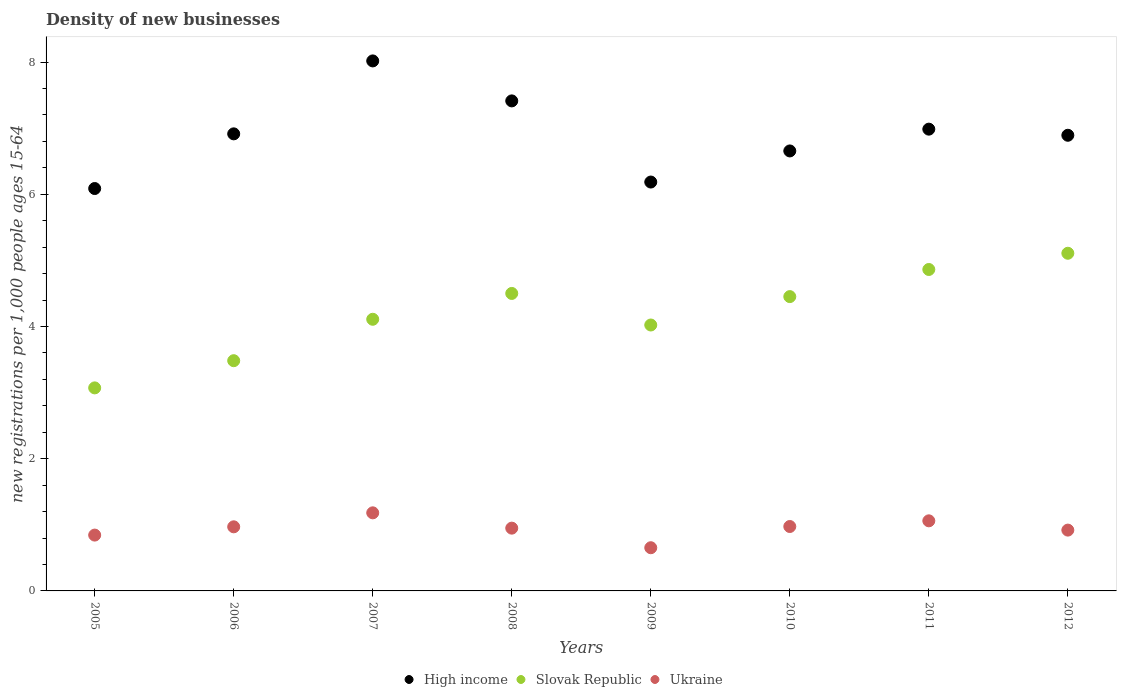What is the number of new registrations in Slovak Republic in 2011?
Give a very brief answer. 4.86. Across all years, what is the maximum number of new registrations in Ukraine?
Your answer should be very brief. 1.18. Across all years, what is the minimum number of new registrations in Ukraine?
Your response must be concise. 0.65. What is the total number of new registrations in Slovak Republic in the graph?
Provide a succinct answer. 33.61. What is the difference between the number of new registrations in High income in 2006 and that in 2009?
Your response must be concise. 0.73. What is the difference between the number of new registrations in High income in 2011 and the number of new registrations in Ukraine in 2009?
Your answer should be compact. 6.33. What is the average number of new registrations in Ukraine per year?
Offer a very short reply. 0.94. In the year 2010, what is the difference between the number of new registrations in Slovak Republic and number of new registrations in High income?
Give a very brief answer. -2.2. What is the ratio of the number of new registrations in Slovak Republic in 2007 to that in 2009?
Give a very brief answer. 1.02. Is the difference between the number of new registrations in Slovak Republic in 2005 and 2011 greater than the difference between the number of new registrations in High income in 2005 and 2011?
Your answer should be compact. No. What is the difference between the highest and the second highest number of new registrations in Ukraine?
Your response must be concise. 0.12. What is the difference between the highest and the lowest number of new registrations in Ukraine?
Offer a very short reply. 0.53. Is the sum of the number of new registrations in High income in 2006 and 2009 greater than the maximum number of new registrations in Slovak Republic across all years?
Your answer should be compact. Yes. Is it the case that in every year, the sum of the number of new registrations in Slovak Republic and number of new registrations in Ukraine  is greater than the number of new registrations in High income?
Give a very brief answer. No. Does the number of new registrations in Ukraine monotonically increase over the years?
Ensure brevity in your answer.  No. Is the number of new registrations in Ukraine strictly less than the number of new registrations in High income over the years?
Provide a succinct answer. Yes. How many dotlines are there?
Provide a short and direct response. 3. How many years are there in the graph?
Your answer should be very brief. 8. Are the values on the major ticks of Y-axis written in scientific E-notation?
Your answer should be compact. No. Does the graph contain grids?
Your answer should be very brief. No. Where does the legend appear in the graph?
Keep it short and to the point. Bottom center. What is the title of the graph?
Your answer should be compact. Density of new businesses. Does "Egypt, Arab Rep." appear as one of the legend labels in the graph?
Provide a short and direct response. No. What is the label or title of the X-axis?
Offer a terse response. Years. What is the label or title of the Y-axis?
Provide a short and direct response. New registrations per 1,0 people ages 15-64. What is the new registrations per 1,000 people ages 15-64 of High income in 2005?
Ensure brevity in your answer.  6.09. What is the new registrations per 1,000 people ages 15-64 in Slovak Republic in 2005?
Provide a short and direct response. 3.07. What is the new registrations per 1,000 people ages 15-64 of Ukraine in 2005?
Your answer should be compact. 0.84. What is the new registrations per 1,000 people ages 15-64 of High income in 2006?
Make the answer very short. 6.91. What is the new registrations per 1,000 people ages 15-64 in Slovak Republic in 2006?
Your answer should be compact. 3.48. What is the new registrations per 1,000 people ages 15-64 of Ukraine in 2006?
Offer a terse response. 0.97. What is the new registrations per 1,000 people ages 15-64 of High income in 2007?
Ensure brevity in your answer.  8.02. What is the new registrations per 1,000 people ages 15-64 in Slovak Republic in 2007?
Provide a short and direct response. 4.11. What is the new registrations per 1,000 people ages 15-64 in Ukraine in 2007?
Your answer should be compact. 1.18. What is the new registrations per 1,000 people ages 15-64 in High income in 2008?
Give a very brief answer. 7.41. What is the new registrations per 1,000 people ages 15-64 of Slovak Republic in 2008?
Offer a terse response. 4.5. What is the new registrations per 1,000 people ages 15-64 in Ukraine in 2008?
Your response must be concise. 0.95. What is the new registrations per 1,000 people ages 15-64 of High income in 2009?
Keep it short and to the point. 6.19. What is the new registrations per 1,000 people ages 15-64 of Slovak Republic in 2009?
Give a very brief answer. 4.02. What is the new registrations per 1,000 people ages 15-64 in Ukraine in 2009?
Your answer should be very brief. 0.65. What is the new registrations per 1,000 people ages 15-64 in High income in 2010?
Your response must be concise. 6.66. What is the new registrations per 1,000 people ages 15-64 in Slovak Republic in 2010?
Ensure brevity in your answer.  4.45. What is the new registrations per 1,000 people ages 15-64 in Ukraine in 2010?
Offer a terse response. 0.97. What is the new registrations per 1,000 people ages 15-64 of High income in 2011?
Ensure brevity in your answer.  6.99. What is the new registrations per 1,000 people ages 15-64 in Slovak Republic in 2011?
Ensure brevity in your answer.  4.86. What is the new registrations per 1,000 people ages 15-64 of Ukraine in 2011?
Ensure brevity in your answer.  1.06. What is the new registrations per 1,000 people ages 15-64 of High income in 2012?
Your response must be concise. 6.89. What is the new registrations per 1,000 people ages 15-64 of Slovak Republic in 2012?
Offer a very short reply. 5.11. Across all years, what is the maximum new registrations per 1,000 people ages 15-64 of High income?
Make the answer very short. 8.02. Across all years, what is the maximum new registrations per 1,000 people ages 15-64 in Slovak Republic?
Your answer should be compact. 5.11. Across all years, what is the maximum new registrations per 1,000 people ages 15-64 in Ukraine?
Give a very brief answer. 1.18. Across all years, what is the minimum new registrations per 1,000 people ages 15-64 of High income?
Your answer should be very brief. 6.09. Across all years, what is the minimum new registrations per 1,000 people ages 15-64 of Slovak Republic?
Offer a terse response. 3.07. Across all years, what is the minimum new registrations per 1,000 people ages 15-64 in Ukraine?
Provide a succinct answer. 0.65. What is the total new registrations per 1,000 people ages 15-64 of High income in the graph?
Ensure brevity in your answer.  55.15. What is the total new registrations per 1,000 people ages 15-64 of Slovak Republic in the graph?
Make the answer very short. 33.61. What is the total new registrations per 1,000 people ages 15-64 of Ukraine in the graph?
Provide a short and direct response. 7.55. What is the difference between the new registrations per 1,000 people ages 15-64 of High income in 2005 and that in 2006?
Your response must be concise. -0.83. What is the difference between the new registrations per 1,000 people ages 15-64 in Slovak Republic in 2005 and that in 2006?
Your response must be concise. -0.41. What is the difference between the new registrations per 1,000 people ages 15-64 in Ukraine in 2005 and that in 2006?
Your answer should be compact. -0.13. What is the difference between the new registrations per 1,000 people ages 15-64 in High income in 2005 and that in 2007?
Your answer should be very brief. -1.93. What is the difference between the new registrations per 1,000 people ages 15-64 of Slovak Republic in 2005 and that in 2007?
Keep it short and to the point. -1.04. What is the difference between the new registrations per 1,000 people ages 15-64 in Ukraine in 2005 and that in 2007?
Offer a very short reply. -0.34. What is the difference between the new registrations per 1,000 people ages 15-64 of High income in 2005 and that in 2008?
Your response must be concise. -1.33. What is the difference between the new registrations per 1,000 people ages 15-64 of Slovak Republic in 2005 and that in 2008?
Your answer should be very brief. -1.43. What is the difference between the new registrations per 1,000 people ages 15-64 of Ukraine in 2005 and that in 2008?
Offer a terse response. -0.11. What is the difference between the new registrations per 1,000 people ages 15-64 of High income in 2005 and that in 2009?
Keep it short and to the point. -0.1. What is the difference between the new registrations per 1,000 people ages 15-64 of Slovak Republic in 2005 and that in 2009?
Offer a terse response. -0.95. What is the difference between the new registrations per 1,000 people ages 15-64 of Ukraine in 2005 and that in 2009?
Offer a very short reply. 0.19. What is the difference between the new registrations per 1,000 people ages 15-64 of High income in 2005 and that in 2010?
Keep it short and to the point. -0.57. What is the difference between the new registrations per 1,000 people ages 15-64 of Slovak Republic in 2005 and that in 2010?
Provide a short and direct response. -1.38. What is the difference between the new registrations per 1,000 people ages 15-64 in Ukraine in 2005 and that in 2010?
Make the answer very short. -0.13. What is the difference between the new registrations per 1,000 people ages 15-64 in High income in 2005 and that in 2011?
Your response must be concise. -0.9. What is the difference between the new registrations per 1,000 people ages 15-64 in Slovak Republic in 2005 and that in 2011?
Your answer should be compact. -1.79. What is the difference between the new registrations per 1,000 people ages 15-64 in Ukraine in 2005 and that in 2011?
Make the answer very short. -0.22. What is the difference between the new registrations per 1,000 people ages 15-64 of High income in 2005 and that in 2012?
Your response must be concise. -0.81. What is the difference between the new registrations per 1,000 people ages 15-64 in Slovak Republic in 2005 and that in 2012?
Provide a succinct answer. -2.04. What is the difference between the new registrations per 1,000 people ages 15-64 of Ukraine in 2005 and that in 2012?
Ensure brevity in your answer.  -0.08. What is the difference between the new registrations per 1,000 people ages 15-64 in High income in 2006 and that in 2007?
Give a very brief answer. -1.1. What is the difference between the new registrations per 1,000 people ages 15-64 of Slovak Republic in 2006 and that in 2007?
Make the answer very short. -0.63. What is the difference between the new registrations per 1,000 people ages 15-64 in Ukraine in 2006 and that in 2007?
Make the answer very short. -0.21. What is the difference between the new registrations per 1,000 people ages 15-64 in High income in 2006 and that in 2008?
Keep it short and to the point. -0.5. What is the difference between the new registrations per 1,000 people ages 15-64 in Slovak Republic in 2006 and that in 2008?
Provide a succinct answer. -1.02. What is the difference between the new registrations per 1,000 people ages 15-64 in Ukraine in 2006 and that in 2008?
Your answer should be compact. 0.02. What is the difference between the new registrations per 1,000 people ages 15-64 in High income in 2006 and that in 2009?
Give a very brief answer. 0.73. What is the difference between the new registrations per 1,000 people ages 15-64 of Slovak Republic in 2006 and that in 2009?
Offer a very short reply. -0.54. What is the difference between the new registrations per 1,000 people ages 15-64 of Ukraine in 2006 and that in 2009?
Give a very brief answer. 0.32. What is the difference between the new registrations per 1,000 people ages 15-64 of High income in 2006 and that in 2010?
Provide a short and direct response. 0.26. What is the difference between the new registrations per 1,000 people ages 15-64 of Slovak Republic in 2006 and that in 2010?
Your answer should be very brief. -0.97. What is the difference between the new registrations per 1,000 people ages 15-64 in Ukraine in 2006 and that in 2010?
Offer a terse response. -0. What is the difference between the new registrations per 1,000 people ages 15-64 of High income in 2006 and that in 2011?
Make the answer very short. -0.07. What is the difference between the new registrations per 1,000 people ages 15-64 in Slovak Republic in 2006 and that in 2011?
Keep it short and to the point. -1.38. What is the difference between the new registrations per 1,000 people ages 15-64 in Ukraine in 2006 and that in 2011?
Your answer should be very brief. -0.09. What is the difference between the new registrations per 1,000 people ages 15-64 in High income in 2006 and that in 2012?
Make the answer very short. 0.02. What is the difference between the new registrations per 1,000 people ages 15-64 of Slovak Republic in 2006 and that in 2012?
Your response must be concise. -1.63. What is the difference between the new registrations per 1,000 people ages 15-64 in Ukraine in 2006 and that in 2012?
Give a very brief answer. 0.05. What is the difference between the new registrations per 1,000 people ages 15-64 in High income in 2007 and that in 2008?
Provide a short and direct response. 0.6. What is the difference between the new registrations per 1,000 people ages 15-64 in Slovak Republic in 2007 and that in 2008?
Your answer should be very brief. -0.39. What is the difference between the new registrations per 1,000 people ages 15-64 of Ukraine in 2007 and that in 2008?
Provide a short and direct response. 0.23. What is the difference between the new registrations per 1,000 people ages 15-64 of High income in 2007 and that in 2009?
Offer a terse response. 1.83. What is the difference between the new registrations per 1,000 people ages 15-64 in Slovak Republic in 2007 and that in 2009?
Keep it short and to the point. 0.09. What is the difference between the new registrations per 1,000 people ages 15-64 of Ukraine in 2007 and that in 2009?
Make the answer very short. 0.53. What is the difference between the new registrations per 1,000 people ages 15-64 of High income in 2007 and that in 2010?
Offer a very short reply. 1.36. What is the difference between the new registrations per 1,000 people ages 15-64 in Slovak Republic in 2007 and that in 2010?
Your answer should be compact. -0.34. What is the difference between the new registrations per 1,000 people ages 15-64 in Ukraine in 2007 and that in 2010?
Offer a very short reply. 0.21. What is the difference between the new registrations per 1,000 people ages 15-64 of High income in 2007 and that in 2011?
Your response must be concise. 1.03. What is the difference between the new registrations per 1,000 people ages 15-64 in Slovak Republic in 2007 and that in 2011?
Your answer should be compact. -0.75. What is the difference between the new registrations per 1,000 people ages 15-64 in Ukraine in 2007 and that in 2011?
Provide a short and direct response. 0.12. What is the difference between the new registrations per 1,000 people ages 15-64 in High income in 2007 and that in 2012?
Make the answer very short. 1.12. What is the difference between the new registrations per 1,000 people ages 15-64 of Slovak Republic in 2007 and that in 2012?
Keep it short and to the point. -1. What is the difference between the new registrations per 1,000 people ages 15-64 of Ukraine in 2007 and that in 2012?
Offer a very short reply. 0.26. What is the difference between the new registrations per 1,000 people ages 15-64 in High income in 2008 and that in 2009?
Offer a terse response. 1.23. What is the difference between the new registrations per 1,000 people ages 15-64 of Slovak Republic in 2008 and that in 2009?
Make the answer very short. 0.48. What is the difference between the new registrations per 1,000 people ages 15-64 in Ukraine in 2008 and that in 2009?
Make the answer very short. 0.3. What is the difference between the new registrations per 1,000 people ages 15-64 in High income in 2008 and that in 2010?
Make the answer very short. 0.76. What is the difference between the new registrations per 1,000 people ages 15-64 in Slovak Republic in 2008 and that in 2010?
Provide a succinct answer. 0.05. What is the difference between the new registrations per 1,000 people ages 15-64 in Ukraine in 2008 and that in 2010?
Ensure brevity in your answer.  -0.02. What is the difference between the new registrations per 1,000 people ages 15-64 of High income in 2008 and that in 2011?
Provide a succinct answer. 0.43. What is the difference between the new registrations per 1,000 people ages 15-64 of Slovak Republic in 2008 and that in 2011?
Your answer should be compact. -0.36. What is the difference between the new registrations per 1,000 people ages 15-64 in Ukraine in 2008 and that in 2011?
Your response must be concise. -0.11. What is the difference between the new registrations per 1,000 people ages 15-64 in High income in 2008 and that in 2012?
Offer a very short reply. 0.52. What is the difference between the new registrations per 1,000 people ages 15-64 of Slovak Republic in 2008 and that in 2012?
Provide a short and direct response. -0.61. What is the difference between the new registrations per 1,000 people ages 15-64 of Ukraine in 2008 and that in 2012?
Offer a very short reply. 0.03. What is the difference between the new registrations per 1,000 people ages 15-64 of High income in 2009 and that in 2010?
Give a very brief answer. -0.47. What is the difference between the new registrations per 1,000 people ages 15-64 in Slovak Republic in 2009 and that in 2010?
Offer a terse response. -0.43. What is the difference between the new registrations per 1,000 people ages 15-64 in Ukraine in 2009 and that in 2010?
Offer a terse response. -0.32. What is the difference between the new registrations per 1,000 people ages 15-64 of High income in 2009 and that in 2011?
Provide a succinct answer. -0.8. What is the difference between the new registrations per 1,000 people ages 15-64 in Slovak Republic in 2009 and that in 2011?
Offer a terse response. -0.84. What is the difference between the new registrations per 1,000 people ages 15-64 of Ukraine in 2009 and that in 2011?
Keep it short and to the point. -0.41. What is the difference between the new registrations per 1,000 people ages 15-64 in High income in 2009 and that in 2012?
Make the answer very short. -0.71. What is the difference between the new registrations per 1,000 people ages 15-64 in Slovak Republic in 2009 and that in 2012?
Give a very brief answer. -1.09. What is the difference between the new registrations per 1,000 people ages 15-64 in Ukraine in 2009 and that in 2012?
Make the answer very short. -0.27. What is the difference between the new registrations per 1,000 people ages 15-64 of High income in 2010 and that in 2011?
Provide a succinct answer. -0.33. What is the difference between the new registrations per 1,000 people ages 15-64 of Slovak Republic in 2010 and that in 2011?
Offer a terse response. -0.41. What is the difference between the new registrations per 1,000 people ages 15-64 in Ukraine in 2010 and that in 2011?
Keep it short and to the point. -0.09. What is the difference between the new registrations per 1,000 people ages 15-64 of High income in 2010 and that in 2012?
Your answer should be compact. -0.24. What is the difference between the new registrations per 1,000 people ages 15-64 in Slovak Republic in 2010 and that in 2012?
Ensure brevity in your answer.  -0.66. What is the difference between the new registrations per 1,000 people ages 15-64 of Ukraine in 2010 and that in 2012?
Offer a very short reply. 0.05. What is the difference between the new registrations per 1,000 people ages 15-64 of High income in 2011 and that in 2012?
Give a very brief answer. 0.09. What is the difference between the new registrations per 1,000 people ages 15-64 of Slovak Republic in 2011 and that in 2012?
Offer a very short reply. -0.25. What is the difference between the new registrations per 1,000 people ages 15-64 of Ukraine in 2011 and that in 2012?
Your answer should be very brief. 0.14. What is the difference between the new registrations per 1,000 people ages 15-64 in High income in 2005 and the new registrations per 1,000 people ages 15-64 in Slovak Republic in 2006?
Offer a very short reply. 2.6. What is the difference between the new registrations per 1,000 people ages 15-64 in High income in 2005 and the new registrations per 1,000 people ages 15-64 in Ukraine in 2006?
Your response must be concise. 5.12. What is the difference between the new registrations per 1,000 people ages 15-64 in Slovak Republic in 2005 and the new registrations per 1,000 people ages 15-64 in Ukraine in 2006?
Provide a succinct answer. 2.1. What is the difference between the new registrations per 1,000 people ages 15-64 of High income in 2005 and the new registrations per 1,000 people ages 15-64 of Slovak Republic in 2007?
Give a very brief answer. 1.98. What is the difference between the new registrations per 1,000 people ages 15-64 in High income in 2005 and the new registrations per 1,000 people ages 15-64 in Ukraine in 2007?
Provide a succinct answer. 4.91. What is the difference between the new registrations per 1,000 people ages 15-64 of Slovak Republic in 2005 and the new registrations per 1,000 people ages 15-64 of Ukraine in 2007?
Give a very brief answer. 1.89. What is the difference between the new registrations per 1,000 people ages 15-64 of High income in 2005 and the new registrations per 1,000 people ages 15-64 of Slovak Republic in 2008?
Your response must be concise. 1.59. What is the difference between the new registrations per 1,000 people ages 15-64 of High income in 2005 and the new registrations per 1,000 people ages 15-64 of Ukraine in 2008?
Give a very brief answer. 5.14. What is the difference between the new registrations per 1,000 people ages 15-64 of Slovak Republic in 2005 and the new registrations per 1,000 people ages 15-64 of Ukraine in 2008?
Ensure brevity in your answer.  2.12. What is the difference between the new registrations per 1,000 people ages 15-64 of High income in 2005 and the new registrations per 1,000 people ages 15-64 of Slovak Republic in 2009?
Ensure brevity in your answer.  2.06. What is the difference between the new registrations per 1,000 people ages 15-64 in High income in 2005 and the new registrations per 1,000 people ages 15-64 in Ukraine in 2009?
Provide a succinct answer. 5.43. What is the difference between the new registrations per 1,000 people ages 15-64 of Slovak Republic in 2005 and the new registrations per 1,000 people ages 15-64 of Ukraine in 2009?
Your answer should be very brief. 2.42. What is the difference between the new registrations per 1,000 people ages 15-64 in High income in 2005 and the new registrations per 1,000 people ages 15-64 in Slovak Republic in 2010?
Ensure brevity in your answer.  1.64. What is the difference between the new registrations per 1,000 people ages 15-64 in High income in 2005 and the new registrations per 1,000 people ages 15-64 in Ukraine in 2010?
Provide a short and direct response. 5.11. What is the difference between the new registrations per 1,000 people ages 15-64 of Slovak Republic in 2005 and the new registrations per 1,000 people ages 15-64 of Ukraine in 2010?
Your answer should be very brief. 2.1. What is the difference between the new registrations per 1,000 people ages 15-64 in High income in 2005 and the new registrations per 1,000 people ages 15-64 in Slovak Republic in 2011?
Give a very brief answer. 1.22. What is the difference between the new registrations per 1,000 people ages 15-64 in High income in 2005 and the new registrations per 1,000 people ages 15-64 in Ukraine in 2011?
Offer a very short reply. 5.03. What is the difference between the new registrations per 1,000 people ages 15-64 in Slovak Republic in 2005 and the new registrations per 1,000 people ages 15-64 in Ukraine in 2011?
Your response must be concise. 2.01. What is the difference between the new registrations per 1,000 people ages 15-64 in High income in 2005 and the new registrations per 1,000 people ages 15-64 in Slovak Republic in 2012?
Make the answer very short. 0.98. What is the difference between the new registrations per 1,000 people ages 15-64 of High income in 2005 and the new registrations per 1,000 people ages 15-64 of Ukraine in 2012?
Your answer should be very brief. 5.17. What is the difference between the new registrations per 1,000 people ages 15-64 of Slovak Republic in 2005 and the new registrations per 1,000 people ages 15-64 of Ukraine in 2012?
Ensure brevity in your answer.  2.15. What is the difference between the new registrations per 1,000 people ages 15-64 in High income in 2006 and the new registrations per 1,000 people ages 15-64 in Slovak Republic in 2007?
Provide a succinct answer. 2.81. What is the difference between the new registrations per 1,000 people ages 15-64 of High income in 2006 and the new registrations per 1,000 people ages 15-64 of Ukraine in 2007?
Provide a short and direct response. 5.73. What is the difference between the new registrations per 1,000 people ages 15-64 in Slovak Republic in 2006 and the new registrations per 1,000 people ages 15-64 in Ukraine in 2007?
Your answer should be very brief. 2.3. What is the difference between the new registrations per 1,000 people ages 15-64 of High income in 2006 and the new registrations per 1,000 people ages 15-64 of Slovak Republic in 2008?
Provide a short and direct response. 2.41. What is the difference between the new registrations per 1,000 people ages 15-64 of High income in 2006 and the new registrations per 1,000 people ages 15-64 of Ukraine in 2008?
Your answer should be compact. 5.96. What is the difference between the new registrations per 1,000 people ages 15-64 of Slovak Republic in 2006 and the new registrations per 1,000 people ages 15-64 of Ukraine in 2008?
Offer a terse response. 2.53. What is the difference between the new registrations per 1,000 people ages 15-64 in High income in 2006 and the new registrations per 1,000 people ages 15-64 in Slovak Republic in 2009?
Provide a short and direct response. 2.89. What is the difference between the new registrations per 1,000 people ages 15-64 in High income in 2006 and the new registrations per 1,000 people ages 15-64 in Ukraine in 2009?
Give a very brief answer. 6.26. What is the difference between the new registrations per 1,000 people ages 15-64 of Slovak Republic in 2006 and the new registrations per 1,000 people ages 15-64 of Ukraine in 2009?
Your response must be concise. 2.83. What is the difference between the new registrations per 1,000 people ages 15-64 of High income in 2006 and the new registrations per 1,000 people ages 15-64 of Slovak Republic in 2010?
Offer a terse response. 2.46. What is the difference between the new registrations per 1,000 people ages 15-64 in High income in 2006 and the new registrations per 1,000 people ages 15-64 in Ukraine in 2010?
Make the answer very short. 5.94. What is the difference between the new registrations per 1,000 people ages 15-64 in Slovak Republic in 2006 and the new registrations per 1,000 people ages 15-64 in Ukraine in 2010?
Keep it short and to the point. 2.51. What is the difference between the new registrations per 1,000 people ages 15-64 of High income in 2006 and the new registrations per 1,000 people ages 15-64 of Slovak Republic in 2011?
Keep it short and to the point. 2.05. What is the difference between the new registrations per 1,000 people ages 15-64 in High income in 2006 and the new registrations per 1,000 people ages 15-64 in Ukraine in 2011?
Keep it short and to the point. 5.85. What is the difference between the new registrations per 1,000 people ages 15-64 in Slovak Republic in 2006 and the new registrations per 1,000 people ages 15-64 in Ukraine in 2011?
Keep it short and to the point. 2.42. What is the difference between the new registrations per 1,000 people ages 15-64 in High income in 2006 and the new registrations per 1,000 people ages 15-64 in Slovak Republic in 2012?
Provide a short and direct response. 1.81. What is the difference between the new registrations per 1,000 people ages 15-64 of High income in 2006 and the new registrations per 1,000 people ages 15-64 of Ukraine in 2012?
Offer a terse response. 5.99. What is the difference between the new registrations per 1,000 people ages 15-64 of Slovak Republic in 2006 and the new registrations per 1,000 people ages 15-64 of Ukraine in 2012?
Your answer should be very brief. 2.56. What is the difference between the new registrations per 1,000 people ages 15-64 in High income in 2007 and the new registrations per 1,000 people ages 15-64 in Slovak Republic in 2008?
Make the answer very short. 3.52. What is the difference between the new registrations per 1,000 people ages 15-64 in High income in 2007 and the new registrations per 1,000 people ages 15-64 in Ukraine in 2008?
Make the answer very short. 7.07. What is the difference between the new registrations per 1,000 people ages 15-64 of Slovak Republic in 2007 and the new registrations per 1,000 people ages 15-64 of Ukraine in 2008?
Give a very brief answer. 3.16. What is the difference between the new registrations per 1,000 people ages 15-64 in High income in 2007 and the new registrations per 1,000 people ages 15-64 in Slovak Republic in 2009?
Offer a terse response. 4. What is the difference between the new registrations per 1,000 people ages 15-64 of High income in 2007 and the new registrations per 1,000 people ages 15-64 of Ukraine in 2009?
Provide a short and direct response. 7.36. What is the difference between the new registrations per 1,000 people ages 15-64 in Slovak Republic in 2007 and the new registrations per 1,000 people ages 15-64 in Ukraine in 2009?
Keep it short and to the point. 3.46. What is the difference between the new registrations per 1,000 people ages 15-64 in High income in 2007 and the new registrations per 1,000 people ages 15-64 in Slovak Republic in 2010?
Offer a terse response. 3.57. What is the difference between the new registrations per 1,000 people ages 15-64 in High income in 2007 and the new registrations per 1,000 people ages 15-64 in Ukraine in 2010?
Provide a succinct answer. 7.04. What is the difference between the new registrations per 1,000 people ages 15-64 in Slovak Republic in 2007 and the new registrations per 1,000 people ages 15-64 in Ukraine in 2010?
Your response must be concise. 3.13. What is the difference between the new registrations per 1,000 people ages 15-64 in High income in 2007 and the new registrations per 1,000 people ages 15-64 in Slovak Republic in 2011?
Offer a very short reply. 3.16. What is the difference between the new registrations per 1,000 people ages 15-64 in High income in 2007 and the new registrations per 1,000 people ages 15-64 in Ukraine in 2011?
Your answer should be very brief. 6.96. What is the difference between the new registrations per 1,000 people ages 15-64 of Slovak Republic in 2007 and the new registrations per 1,000 people ages 15-64 of Ukraine in 2011?
Your response must be concise. 3.05. What is the difference between the new registrations per 1,000 people ages 15-64 of High income in 2007 and the new registrations per 1,000 people ages 15-64 of Slovak Republic in 2012?
Ensure brevity in your answer.  2.91. What is the difference between the new registrations per 1,000 people ages 15-64 of High income in 2007 and the new registrations per 1,000 people ages 15-64 of Ukraine in 2012?
Give a very brief answer. 7.1. What is the difference between the new registrations per 1,000 people ages 15-64 in Slovak Republic in 2007 and the new registrations per 1,000 people ages 15-64 in Ukraine in 2012?
Give a very brief answer. 3.19. What is the difference between the new registrations per 1,000 people ages 15-64 in High income in 2008 and the new registrations per 1,000 people ages 15-64 in Slovak Republic in 2009?
Your answer should be compact. 3.39. What is the difference between the new registrations per 1,000 people ages 15-64 of High income in 2008 and the new registrations per 1,000 people ages 15-64 of Ukraine in 2009?
Provide a short and direct response. 6.76. What is the difference between the new registrations per 1,000 people ages 15-64 of Slovak Republic in 2008 and the new registrations per 1,000 people ages 15-64 of Ukraine in 2009?
Your answer should be compact. 3.85. What is the difference between the new registrations per 1,000 people ages 15-64 of High income in 2008 and the new registrations per 1,000 people ages 15-64 of Slovak Republic in 2010?
Your response must be concise. 2.96. What is the difference between the new registrations per 1,000 people ages 15-64 of High income in 2008 and the new registrations per 1,000 people ages 15-64 of Ukraine in 2010?
Provide a succinct answer. 6.44. What is the difference between the new registrations per 1,000 people ages 15-64 of Slovak Republic in 2008 and the new registrations per 1,000 people ages 15-64 of Ukraine in 2010?
Offer a very short reply. 3.53. What is the difference between the new registrations per 1,000 people ages 15-64 in High income in 2008 and the new registrations per 1,000 people ages 15-64 in Slovak Republic in 2011?
Your answer should be compact. 2.55. What is the difference between the new registrations per 1,000 people ages 15-64 of High income in 2008 and the new registrations per 1,000 people ages 15-64 of Ukraine in 2011?
Offer a terse response. 6.35. What is the difference between the new registrations per 1,000 people ages 15-64 in Slovak Republic in 2008 and the new registrations per 1,000 people ages 15-64 in Ukraine in 2011?
Provide a short and direct response. 3.44. What is the difference between the new registrations per 1,000 people ages 15-64 in High income in 2008 and the new registrations per 1,000 people ages 15-64 in Slovak Republic in 2012?
Your answer should be very brief. 2.31. What is the difference between the new registrations per 1,000 people ages 15-64 in High income in 2008 and the new registrations per 1,000 people ages 15-64 in Ukraine in 2012?
Provide a short and direct response. 6.49. What is the difference between the new registrations per 1,000 people ages 15-64 of Slovak Republic in 2008 and the new registrations per 1,000 people ages 15-64 of Ukraine in 2012?
Offer a terse response. 3.58. What is the difference between the new registrations per 1,000 people ages 15-64 in High income in 2009 and the new registrations per 1,000 people ages 15-64 in Slovak Republic in 2010?
Give a very brief answer. 1.73. What is the difference between the new registrations per 1,000 people ages 15-64 in High income in 2009 and the new registrations per 1,000 people ages 15-64 in Ukraine in 2010?
Offer a terse response. 5.21. What is the difference between the new registrations per 1,000 people ages 15-64 in Slovak Republic in 2009 and the new registrations per 1,000 people ages 15-64 in Ukraine in 2010?
Keep it short and to the point. 3.05. What is the difference between the new registrations per 1,000 people ages 15-64 of High income in 2009 and the new registrations per 1,000 people ages 15-64 of Slovak Republic in 2011?
Offer a terse response. 1.32. What is the difference between the new registrations per 1,000 people ages 15-64 of High income in 2009 and the new registrations per 1,000 people ages 15-64 of Ukraine in 2011?
Your answer should be very brief. 5.13. What is the difference between the new registrations per 1,000 people ages 15-64 of Slovak Republic in 2009 and the new registrations per 1,000 people ages 15-64 of Ukraine in 2011?
Keep it short and to the point. 2.96. What is the difference between the new registrations per 1,000 people ages 15-64 in High income in 2009 and the new registrations per 1,000 people ages 15-64 in Slovak Republic in 2012?
Ensure brevity in your answer.  1.08. What is the difference between the new registrations per 1,000 people ages 15-64 in High income in 2009 and the new registrations per 1,000 people ages 15-64 in Ukraine in 2012?
Give a very brief answer. 5.27. What is the difference between the new registrations per 1,000 people ages 15-64 in Slovak Republic in 2009 and the new registrations per 1,000 people ages 15-64 in Ukraine in 2012?
Offer a very short reply. 3.1. What is the difference between the new registrations per 1,000 people ages 15-64 in High income in 2010 and the new registrations per 1,000 people ages 15-64 in Slovak Republic in 2011?
Your response must be concise. 1.79. What is the difference between the new registrations per 1,000 people ages 15-64 of High income in 2010 and the new registrations per 1,000 people ages 15-64 of Ukraine in 2011?
Provide a short and direct response. 5.6. What is the difference between the new registrations per 1,000 people ages 15-64 in Slovak Republic in 2010 and the new registrations per 1,000 people ages 15-64 in Ukraine in 2011?
Your answer should be very brief. 3.39. What is the difference between the new registrations per 1,000 people ages 15-64 of High income in 2010 and the new registrations per 1,000 people ages 15-64 of Slovak Republic in 2012?
Provide a succinct answer. 1.55. What is the difference between the new registrations per 1,000 people ages 15-64 of High income in 2010 and the new registrations per 1,000 people ages 15-64 of Ukraine in 2012?
Keep it short and to the point. 5.74. What is the difference between the new registrations per 1,000 people ages 15-64 of Slovak Republic in 2010 and the new registrations per 1,000 people ages 15-64 of Ukraine in 2012?
Your answer should be very brief. 3.53. What is the difference between the new registrations per 1,000 people ages 15-64 in High income in 2011 and the new registrations per 1,000 people ages 15-64 in Slovak Republic in 2012?
Your response must be concise. 1.88. What is the difference between the new registrations per 1,000 people ages 15-64 in High income in 2011 and the new registrations per 1,000 people ages 15-64 in Ukraine in 2012?
Offer a terse response. 6.07. What is the difference between the new registrations per 1,000 people ages 15-64 in Slovak Republic in 2011 and the new registrations per 1,000 people ages 15-64 in Ukraine in 2012?
Provide a short and direct response. 3.94. What is the average new registrations per 1,000 people ages 15-64 in High income per year?
Offer a terse response. 6.89. What is the average new registrations per 1,000 people ages 15-64 in Slovak Republic per year?
Provide a succinct answer. 4.2. What is the average new registrations per 1,000 people ages 15-64 in Ukraine per year?
Make the answer very short. 0.94. In the year 2005, what is the difference between the new registrations per 1,000 people ages 15-64 of High income and new registrations per 1,000 people ages 15-64 of Slovak Republic?
Provide a short and direct response. 3.02. In the year 2005, what is the difference between the new registrations per 1,000 people ages 15-64 of High income and new registrations per 1,000 people ages 15-64 of Ukraine?
Provide a short and direct response. 5.24. In the year 2005, what is the difference between the new registrations per 1,000 people ages 15-64 of Slovak Republic and new registrations per 1,000 people ages 15-64 of Ukraine?
Give a very brief answer. 2.23. In the year 2006, what is the difference between the new registrations per 1,000 people ages 15-64 of High income and new registrations per 1,000 people ages 15-64 of Slovak Republic?
Make the answer very short. 3.43. In the year 2006, what is the difference between the new registrations per 1,000 people ages 15-64 in High income and new registrations per 1,000 people ages 15-64 in Ukraine?
Provide a succinct answer. 5.94. In the year 2006, what is the difference between the new registrations per 1,000 people ages 15-64 of Slovak Republic and new registrations per 1,000 people ages 15-64 of Ukraine?
Offer a very short reply. 2.51. In the year 2007, what is the difference between the new registrations per 1,000 people ages 15-64 in High income and new registrations per 1,000 people ages 15-64 in Slovak Republic?
Provide a succinct answer. 3.91. In the year 2007, what is the difference between the new registrations per 1,000 people ages 15-64 in High income and new registrations per 1,000 people ages 15-64 in Ukraine?
Provide a succinct answer. 6.84. In the year 2007, what is the difference between the new registrations per 1,000 people ages 15-64 in Slovak Republic and new registrations per 1,000 people ages 15-64 in Ukraine?
Provide a short and direct response. 2.93. In the year 2008, what is the difference between the new registrations per 1,000 people ages 15-64 of High income and new registrations per 1,000 people ages 15-64 of Slovak Republic?
Offer a terse response. 2.91. In the year 2008, what is the difference between the new registrations per 1,000 people ages 15-64 in High income and new registrations per 1,000 people ages 15-64 in Ukraine?
Make the answer very short. 6.46. In the year 2008, what is the difference between the new registrations per 1,000 people ages 15-64 in Slovak Republic and new registrations per 1,000 people ages 15-64 in Ukraine?
Your answer should be very brief. 3.55. In the year 2009, what is the difference between the new registrations per 1,000 people ages 15-64 in High income and new registrations per 1,000 people ages 15-64 in Slovak Republic?
Your answer should be very brief. 2.16. In the year 2009, what is the difference between the new registrations per 1,000 people ages 15-64 of High income and new registrations per 1,000 people ages 15-64 of Ukraine?
Offer a very short reply. 5.53. In the year 2009, what is the difference between the new registrations per 1,000 people ages 15-64 of Slovak Republic and new registrations per 1,000 people ages 15-64 of Ukraine?
Your answer should be compact. 3.37. In the year 2010, what is the difference between the new registrations per 1,000 people ages 15-64 of High income and new registrations per 1,000 people ages 15-64 of Slovak Republic?
Your answer should be very brief. 2.2. In the year 2010, what is the difference between the new registrations per 1,000 people ages 15-64 of High income and new registrations per 1,000 people ages 15-64 of Ukraine?
Make the answer very short. 5.68. In the year 2010, what is the difference between the new registrations per 1,000 people ages 15-64 of Slovak Republic and new registrations per 1,000 people ages 15-64 of Ukraine?
Provide a succinct answer. 3.48. In the year 2011, what is the difference between the new registrations per 1,000 people ages 15-64 in High income and new registrations per 1,000 people ages 15-64 in Slovak Republic?
Provide a short and direct response. 2.12. In the year 2011, what is the difference between the new registrations per 1,000 people ages 15-64 in High income and new registrations per 1,000 people ages 15-64 in Ukraine?
Your answer should be compact. 5.93. In the year 2011, what is the difference between the new registrations per 1,000 people ages 15-64 of Slovak Republic and new registrations per 1,000 people ages 15-64 of Ukraine?
Keep it short and to the point. 3.8. In the year 2012, what is the difference between the new registrations per 1,000 people ages 15-64 of High income and new registrations per 1,000 people ages 15-64 of Slovak Republic?
Give a very brief answer. 1.79. In the year 2012, what is the difference between the new registrations per 1,000 people ages 15-64 of High income and new registrations per 1,000 people ages 15-64 of Ukraine?
Your response must be concise. 5.97. In the year 2012, what is the difference between the new registrations per 1,000 people ages 15-64 of Slovak Republic and new registrations per 1,000 people ages 15-64 of Ukraine?
Provide a succinct answer. 4.19. What is the ratio of the new registrations per 1,000 people ages 15-64 in High income in 2005 to that in 2006?
Ensure brevity in your answer.  0.88. What is the ratio of the new registrations per 1,000 people ages 15-64 of Slovak Republic in 2005 to that in 2006?
Make the answer very short. 0.88. What is the ratio of the new registrations per 1,000 people ages 15-64 in Ukraine in 2005 to that in 2006?
Your answer should be very brief. 0.87. What is the ratio of the new registrations per 1,000 people ages 15-64 of High income in 2005 to that in 2007?
Make the answer very short. 0.76. What is the ratio of the new registrations per 1,000 people ages 15-64 of Slovak Republic in 2005 to that in 2007?
Provide a short and direct response. 0.75. What is the ratio of the new registrations per 1,000 people ages 15-64 in Ukraine in 2005 to that in 2007?
Offer a very short reply. 0.71. What is the ratio of the new registrations per 1,000 people ages 15-64 in High income in 2005 to that in 2008?
Offer a very short reply. 0.82. What is the ratio of the new registrations per 1,000 people ages 15-64 of Slovak Republic in 2005 to that in 2008?
Make the answer very short. 0.68. What is the ratio of the new registrations per 1,000 people ages 15-64 in Ukraine in 2005 to that in 2008?
Provide a succinct answer. 0.89. What is the ratio of the new registrations per 1,000 people ages 15-64 of High income in 2005 to that in 2009?
Ensure brevity in your answer.  0.98. What is the ratio of the new registrations per 1,000 people ages 15-64 in Slovak Republic in 2005 to that in 2009?
Offer a terse response. 0.76. What is the ratio of the new registrations per 1,000 people ages 15-64 of Ukraine in 2005 to that in 2009?
Your answer should be very brief. 1.29. What is the ratio of the new registrations per 1,000 people ages 15-64 in High income in 2005 to that in 2010?
Ensure brevity in your answer.  0.91. What is the ratio of the new registrations per 1,000 people ages 15-64 of Slovak Republic in 2005 to that in 2010?
Provide a succinct answer. 0.69. What is the ratio of the new registrations per 1,000 people ages 15-64 of Ukraine in 2005 to that in 2010?
Your answer should be compact. 0.87. What is the ratio of the new registrations per 1,000 people ages 15-64 of High income in 2005 to that in 2011?
Provide a succinct answer. 0.87. What is the ratio of the new registrations per 1,000 people ages 15-64 in Slovak Republic in 2005 to that in 2011?
Keep it short and to the point. 0.63. What is the ratio of the new registrations per 1,000 people ages 15-64 of Ukraine in 2005 to that in 2011?
Your response must be concise. 0.8. What is the ratio of the new registrations per 1,000 people ages 15-64 of High income in 2005 to that in 2012?
Offer a very short reply. 0.88. What is the ratio of the new registrations per 1,000 people ages 15-64 in Slovak Republic in 2005 to that in 2012?
Ensure brevity in your answer.  0.6. What is the ratio of the new registrations per 1,000 people ages 15-64 in Ukraine in 2005 to that in 2012?
Provide a succinct answer. 0.92. What is the ratio of the new registrations per 1,000 people ages 15-64 of High income in 2006 to that in 2007?
Ensure brevity in your answer.  0.86. What is the ratio of the new registrations per 1,000 people ages 15-64 in Slovak Republic in 2006 to that in 2007?
Provide a succinct answer. 0.85. What is the ratio of the new registrations per 1,000 people ages 15-64 of Ukraine in 2006 to that in 2007?
Provide a short and direct response. 0.82. What is the ratio of the new registrations per 1,000 people ages 15-64 in High income in 2006 to that in 2008?
Give a very brief answer. 0.93. What is the ratio of the new registrations per 1,000 people ages 15-64 in Slovak Republic in 2006 to that in 2008?
Provide a succinct answer. 0.77. What is the ratio of the new registrations per 1,000 people ages 15-64 in Ukraine in 2006 to that in 2008?
Give a very brief answer. 1.02. What is the ratio of the new registrations per 1,000 people ages 15-64 in High income in 2006 to that in 2009?
Keep it short and to the point. 1.12. What is the ratio of the new registrations per 1,000 people ages 15-64 of Slovak Republic in 2006 to that in 2009?
Make the answer very short. 0.87. What is the ratio of the new registrations per 1,000 people ages 15-64 in Ukraine in 2006 to that in 2009?
Provide a succinct answer. 1.48. What is the ratio of the new registrations per 1,000 people ages 15-64 of High income in 2006 to that in 2010?
Make the answer very short. 1.04. What is the ratio of the new registrations per 1,000 people ages 15-64 in Slovak Republic in 2006 to that in 2010?
Ensure brevity in your answer.  0.78. What is the ratio of the new registrations per 1,000 people ages 15-64 in Ukraine in 2006 to that in 2010?
Make the answer very short. 1. What is the ratio of the new registrations per 1,000 people ages 15-64 of Slovak Republic in 2006 to that in 2011?
Offer a terse response. 0.72. What is the ratio of the new registrations per 1,000 people ages 15-64 in Ukraine in 2006 to that in 2011?
Provide a succinct answer. 0.91. What is the ratio of the new registrations per 1,000 people ages 15-64 of Slovak Republic in 2006 to that in 2012?
Keep it short and to the point. 0.68. What is the ratio of the new registrations per 1,000 people ages 15-64 of Ukraine in 2006 to that in 2012?
Offer a very short reply. 1.05. What is the ratio of the new registrations per 1,000 people ages 15-64 in High income in 2007 to that in 2008?
Your response must be concise. 1.08. What is the ratio of the new registrations per 1,000 people ages 15-64 in Slovak Republic in 2007 to that in 2008?
Keep it short and to the point. 0.91. What is the ratio of the new registrations per 1,000 people ages 15-64 in Ukraine in 2007 to that in 2008?
Offer a very short reply. 1.24. What is the ratio of the new registrations per 1,000 people ages 15-64 of High income in 2007 to that in 2009?
Make the answer very short. 1.3. What is the ratio of the new registrations per 1,000 people ages 15-64 of Slovak Republic in 2007 to that in 2009?
Provide a short and direct response. 1.02. What is the ratio of the new registrations per 1,000 people ages 15-64 in Ukraine in 2007 to that in 2009?
Ensure brevity in your answer.  1.81. What is the ratio of the new registrations per 1,000 people ages 15-64 in High income in 2007 to that in 2010?
Your answer should be compact. 1.2. What is the ratio of the new registrations per 1,000 people ages 15-64 of Slovak Republic in 2007 to that in 2010?
Your answer should be very brief. 0.92. What is the ratio of the new registrations per 1,000 people ages 15-64 in Ukraine in 2007 to that in 2010?
Offer a terse response. 1.21. What is the ratio of the new registrations per 1,000 people ages 15-64 of High income in 2007 to that in 2011?
Your answer should be compact. 1.15. What is the ratio of the new registrations per 1,000 people ages 15-64 in Slovak Republic in 2007 to that in 2011?
Ensure brevity in your answer.  0.85. What is the ratio of the new registrations per 1,000 people ages 15-64 of Ukraine in 2007 to that in 2011?
Provide a succinct answer. 1.11. What is the ratio of the new registrations per 1,000 people ages 15-64 in High income in 2007 to that in 2012?
Offer a terse response. 1.16. What is the ratio of the new registrations per 1,000 people ages 15-64 of Slovak Republic in 2007 to that in 2012?
Offer a very short reply. 0.8. What is the ratio of the new registrations per 1,000 people ages 15-64 in Ukraine in 2007 to that in 2012?
Offer a very short reply. 1.28. What is the ratio of the new registrations per 1,000 people ages 15-64 in High income in 2008 to that in 2009?
Provide a succinct answer. 1.2. What is the ratio of the new registrations per 1,000 people ages 15-64 in Slovak Republic in 2008 to that in 2009?
Give a very brief answer. 1.12. What is the ratio of the new registrations per 1,000 people ages 15-64 of Ukraine in 2008 to that in 2009?
Ensure brevity in your answer.  1.45. What is the ratio of the new registrations per 1,000 people ages 15-64 of High income in 2008 to that in 2010?
Provide a short and direct response. 1.11. What is the ratio of the new registrations per 1,000 people ages 15-64 in Slovak Republic in 2008 to that in 2010?
Your answer should be compact. 1.01. What is the ratio of the new registrations per 1,000 people ages 15-64 in Ukraine in 2008 to that in 2010?
Give a very brief answer. 0.97. What is the ratio of the new registrations per 1,000 people ages 15-64 in High income in 2008 to that in 2011?
Offer a very short reply. 1.06. What is the ratio of the new registrations per 1,000 people ages 15-64 in Slovak Republic in 2008 to that in 2011?
Give a very brief answer. 0.93. What is the ratio of the new registrations per 1,000 people ages 15-64 in Ukraine in 2008 to that in 2011?
Offer a very short reply. 0.9. What is the ratio of the new registrations per 1,000 people ages 15-64 in High income in 2008 to that in 2012?
Make the answer very short. 1.08. What is the ratio of the new registrations per 1,000 people ages 15-64 in Slovak Republic in 2008 to that in 2012?
Provide a succinct answer. 0.88. What is the ratio of the new registrations per 1,000 people ages 15-64 in Ukraine in 2008 to that in 2012?
Give a very brief answer. 1.03. What is the ratio of the new registrations per 1,000 people ages 15-64 in High income in 2009 to that in 2010?
Your response must be concise. 0.93. What is the ratio of the new registrations per 1,000 people ages 15-64 in Slovak Republic in 2009 to that in 2010?
Your answer should be very brief. 0.9. What is the ratio of the new registrations per 1,000 people ages 15-64 of Ukraine in 2009 to that in 2010?
Keep it short and to the point. 0.67. What is the ratio of the new registrations per 1,000 people ages 15-64 in High income in 2009 to that in 2011?
Keep it short and to the point. 0.89. What is the ratio of the new registrations per 1,000 people ages 15-64 in Slovak Republic in 2009 to that in 2011?
Your response must be concise. 0.83. What is the ratio of the new registrations per 1,000 people ages 15-64 in Ukraine in 2009 to that in 2011?
Provide a succinct answer. 0.62. What is the ratio of the new registrations per 1,000 people ages 15-64 in High income in 2009 to that in 2012?
Your answer should be compact. 0.9. What is the ratio of the new registrations per 1,000 people ages 15-64 of Slovak Republic in 2009 to that in 2012?
Keep it short and to the point. 0.79. What is the ratio of the new registrations per 1,000 people ages 15-64 in Ukraine in 2009 to that in 2012?
Your response must be concise. 0.71. What is the ratio of the new registrations per 1,000 people ages 15-64 of High income in 2010 to that in 2011?
Keep it short and to the point. 0.95. What is the ratio of the new registrations per 1,000 people ages 15-64 in Slovak Republic in 2010 to that in 2011?
Provide a succinct answer. 0.92. What is the ratio of the new registrations per 1,000 people ages 15-64 of Ukraine in 2010 to that in 2011?
Make the answer very short. 0.92. What is the ratio of the new registrations per 1,000 people ages 15-64 in High income in 2010 to that in 2012?
Your answer should be very brief. 0.97. What is the ratio of the new registrations per 1,000 people ages 15-64 of Slovak Republic in 2010 to that in 2012?
Provide a succinct answer. 0.87. What is the ratio of the new registrations per 1,000 people ages 15-64 in Ukraine in 2010 to that in 2012?
Make the answer very short. 1.06. What is the ratio of the new registrations per 1,000 people ages 15-64 of High income in 2011 to that in 2012?
Offer a terse response. 1.01. What is the ratio of the new registrations per 1,000 people ages 15-64 in Ukraine in 2011 to that in 2012?
Offer a terse response. 1.15. What is the difference between the highest and the second highest new registrations per 1,000 people ages 15-64 in High income?
Your answer should be very brief. 0.6. What is the difference between the highest and the second highest new registrations per 1,000 people ages 15-64 of Slovak Republic?
Keep it short and to the point. 0.25. What is the difference between the highest and the second highest new registrations per 1,000 people ages 15-64 of Ukraine?
Offer a terse response. 0.12. What is the difference between the highest and the lowest new registrations per 1,000 people ages 15-64 of High income?
Your response must be concise. 1.93. What is the difference between the highest and the lowest new registrations per 1,000 people ages 15-64 in Slovak Republic?
Your answer should be very brief. 2.04. What is the difference between the highest and the lowest new registrations per 1,000 people ages 15-64 in Ukraine?
Provide a succinct answer. 0.53. 